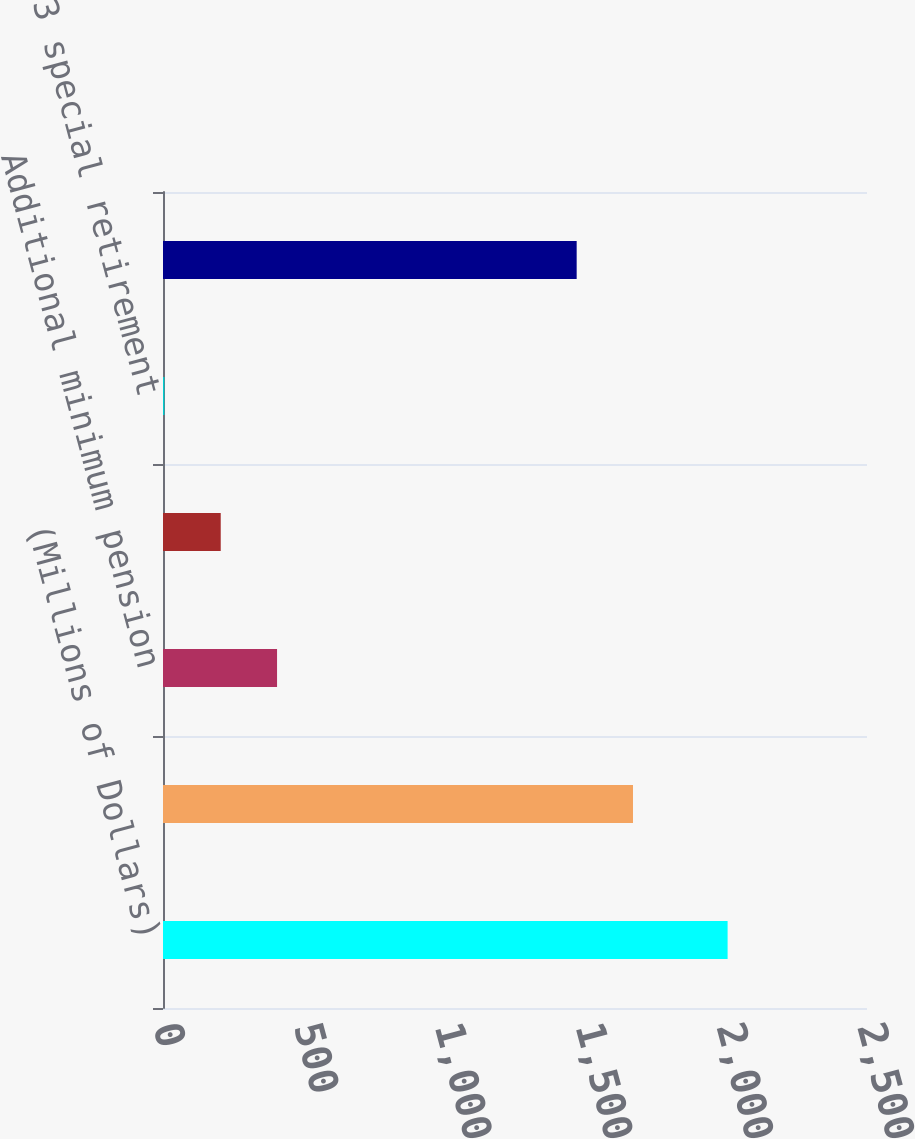Convert chart. <chart><loc_0><loc_0><loc_500><loc_500><bar_chart><fcel>(Millions of Dollars)<fcel>Prepaid pension cost<fcel>Additional minimum pension<fcel>Accumulated other<fcel>1993 special retirement<fcel>Net prepaid benefit cost<nl><fcel>2005<fcel>1669<fcel>405<fcel>205<fcel>5<fcel>1469<nl></chart> 